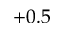<formula> <loc_0><loc_0><loc_500><loc_500>+ 0 . 5</formula> 